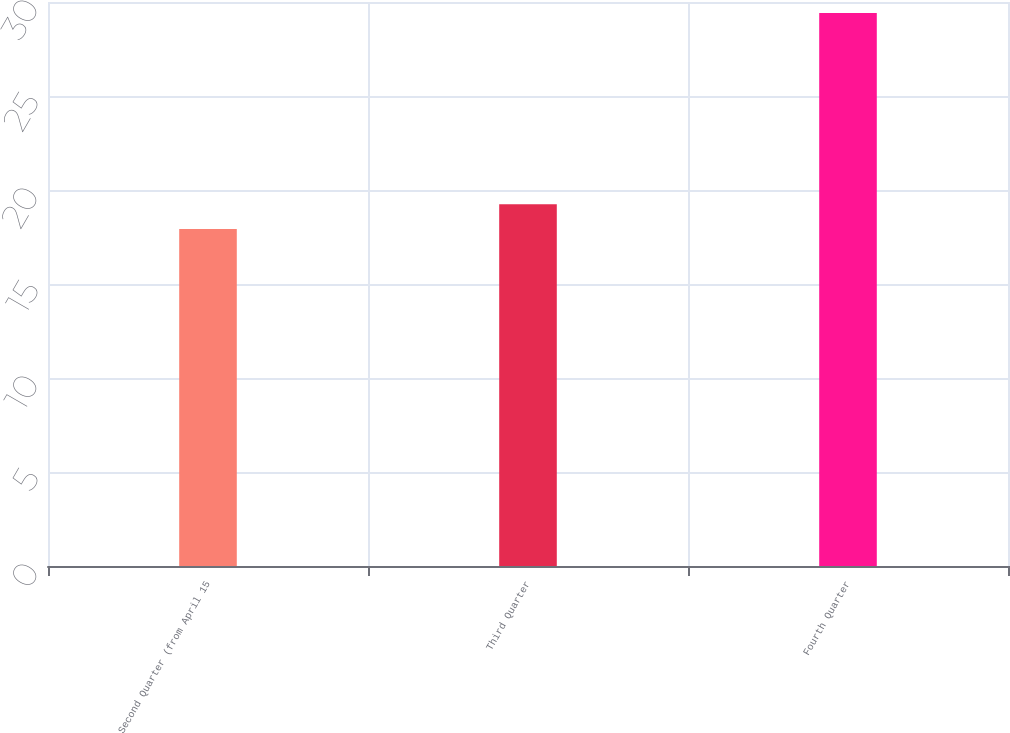Convert chart to OTSL. <chart><loc_0><loc_0><loc_500><loc_500><bar_chart><fcel>Second Quarter (from April 15<fcel>Third Quarter<fcel>Fourth Quarter<nl><fcel>17.92<fcel>19.24<fcel>29.42<nl></chart> 